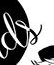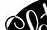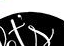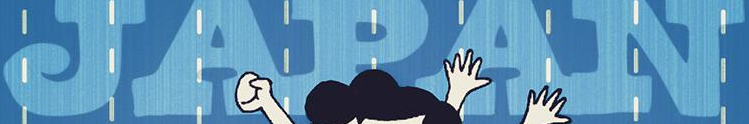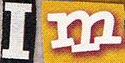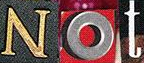Transcribe the words shown in these images in order, separated by a semicolon. ds; ##; t's; JAPAN; Im; Not 